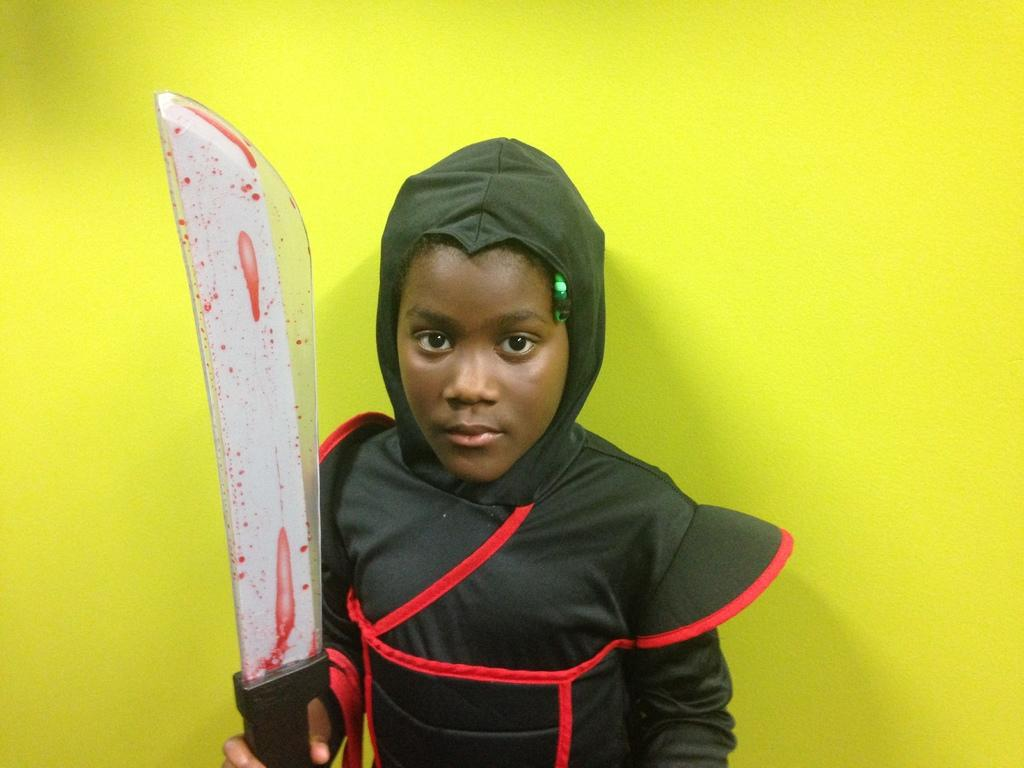What is the main subject of the image? The main subject of the image is a kid. What is the kid wearing in the image? The kid is wearing a costume in the image. What is the kid holding in his hand? The kid is holding a sword in his hand. What can be seen in the background of the image? There is a wall in the background of the image. How many dogs are present in the image? There are no dogs present in the image. What type of snake can be seen slithering on the wall in the image? There is no snake present in the image; only the kid, his costume, sword, and the wall are visible. 